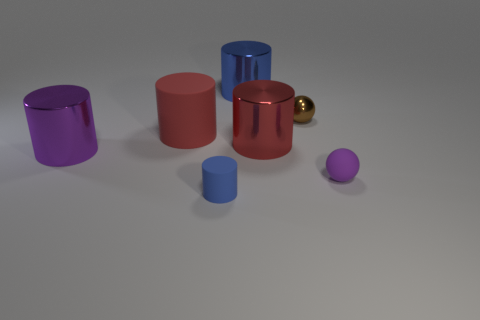Subtract all large blue cylinders. How many cylinders are left? 4 Subtract all purple spheres. How many spheres are left? 1 Add 1 red objects. How many objects exist? 8 Subtract all cylinders. How many objects are left? 2 Subtract 1 cylinders. How many cylinders are left? 4 Subtract all blue cylinders. Subtract all brown blocks. How many cylinders are left? 3 Subtract all red cylinders. How many blue balls are left? 0 Subtract all matte cylinders. Subtract all brown metallic balls. How many objects are left? 4 Add 7 red cylinders. How many red cylinders are left? 9 Add 6 large red rubber cylinders. How many large red rubber cylinders exist? 7 